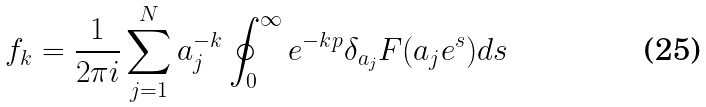<formula> <loc_0><loc_0><loc_500><loc_500>f _ { k } = \frac { 1 } { 2 \pi i } \sum _ { j = 1 } ^ { N } a _ { j } ^ { - k } \oint _ { 0 } ^ { \infty } e ^ { - k p } \delta _ { a _ { j } } F ( a _ { j } e ^ { s } ) d s</formula> 